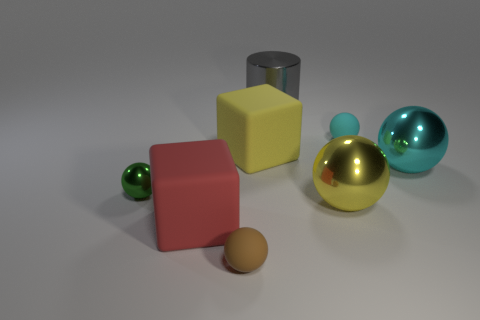What shapes and colors do you see in this image? The image features a variety of geometric shapes, including a large yellow cube, a red cuboid, a silver cylinder, and several spheres in different sizes and colors like green, gold, and teal. 